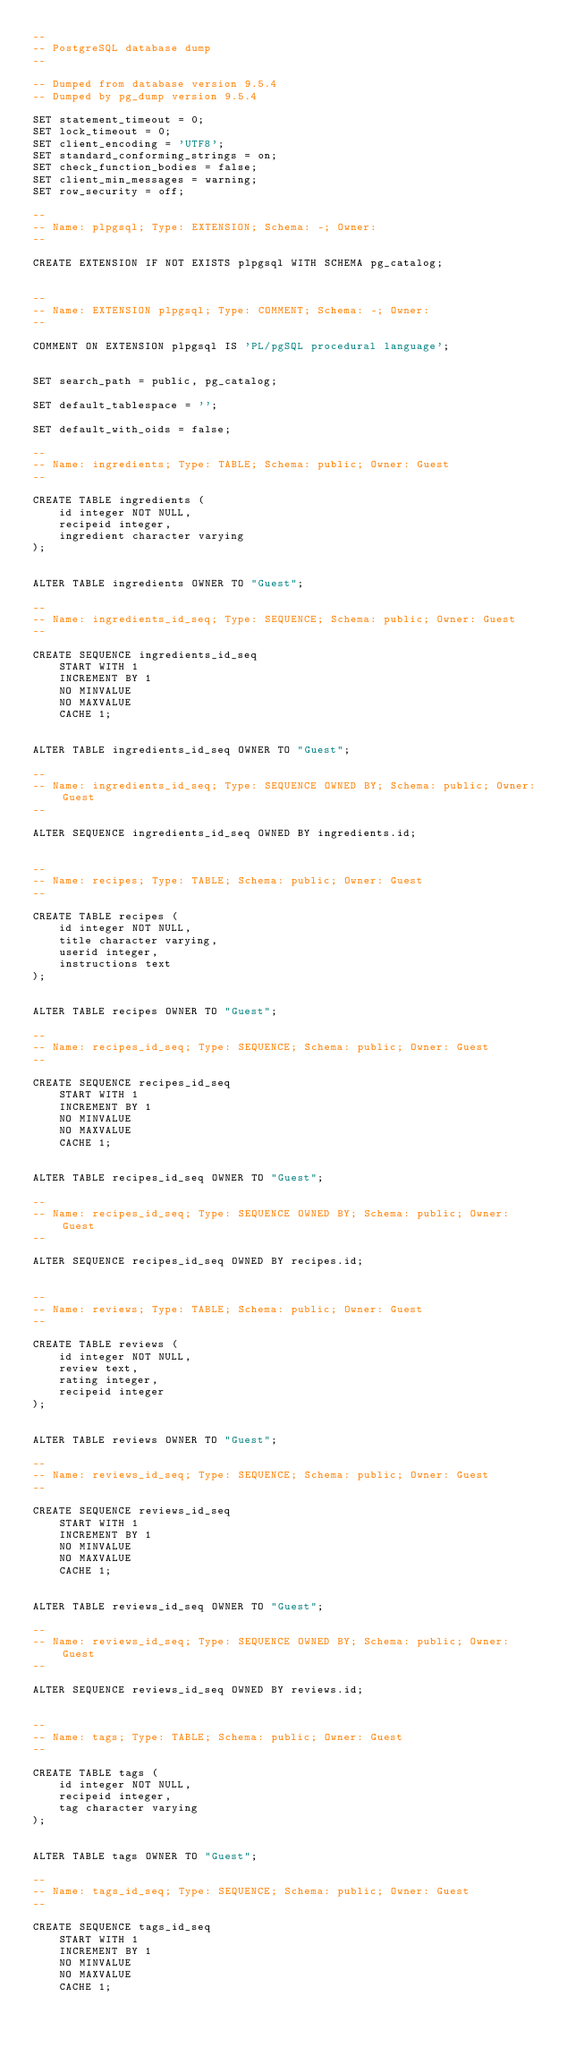<code> <loc_0><loc_0><loc_500><loc_500><_SQL_>--
-- PostgreSQL database dump
--

-- Dumped from database version 9.5.4
-- Dumped by pg_dump version 9.5.4

SET statement_timeout = 0;
SET lock_timeout = 0;
SET client_encoding = 'UTF8';
SET standard_conforming_strings = on;
SET check_function_bodies = false;
SET client_min_messages = warning;
SET row_security = off;

--
-- Name: plpgsql; Type: EXTENSION; Schema: -; Owner: 
--

CREATE EXTENSION IF NOT EXISTS plpgsql WITH SCHEMA pg_catalog;


--
-- Name: EXTENSION plpgsql; Type: COMMENT; Schema: -; Owner: 
--

COMMENT ON EXTENSION plpgsql IS 'PL/pgSQL procedural language';


SET search_path = public, pg_catalog;

SET default_tablespace = '';

SET default_with_oids = false;

--
-- Name: ingredients; Type: TABLE; Schema: public; Owner: Guest
--

CREATE TABLE ingredients (
    id integer NOT NULL,
    recipeid integer,
    ingredient character varying
);


ALTER TABLE ingredients OWNER TO "Guest";

--
-- Name: ingredients_id_seq; Type: SEQUENCE; Schema: public; Owner: Guest
--

CREATE SEQUENCE ingredients_id_seq
    START WITH 1
    INCREMENT BY 1
    NO MINVALUE
    NO MAXVALUE
    CACHE 1;


ALTER TABLE ingredients_id_seq OWNER TO "Guest";

--
-- Name: ingredients_id_seq; Type: SEQUENCE OWNED BY; Schema: public; Owner: Guest
--

ALTER SEQUENCE ingredients_id_seq OWNED BY ingredients.id;


--
-- Name: recipes; Type: TABLE; Schema: public; Owner: Guest
--

CREATE TABLE recipes (
    id integer NOT NULL,
    title character varying,
    userid integer,
    instructions text
);


ALTER TABLE recipes OWNER TO "Guest";

--
-- Name: recipes_id_seq; Type: SEQUENCE; Schema: public; Owner: Guest
--

CREATE SEQUENCE recipes_id_seq
    START WITH 1
    INCREMENT BY 1
    NO MINVALUE
    NO MAXVALUE
    CACHE 1;


ALTER TABLE recipes_id_seq OWNER TO "Guest";

--
-- Name: recipes_id_seq; Type: SEQUENCE OWNED BY; Schema: public; Owner: Guest
--

ALTER SEQUENCE recipes_id_seq OWNED BY recipes.id;


--
-- Name: reviews; Type: TABLE; Schema: public; Owner: Guest
--

CREATE TABLE reviews (
    id integer NOT NULL,
    review text,
    rating integer,
    recipeid integer
);


ALTER TABLE reviews OWNER TO "Guest";

--
-- Name: reviews_id_seq; Type: SEQUENCE; Schema: public; Owner: Guest
--

CREATE SEQUENCE reviews_id_seq
    START WITH 1
    INCREMENT BY 1
    NO MINVALUE
    NO MAXVALUE
    CACHE 1;


ALTER TABLE reviews_id_seq OWNER TO "Guest";

--
-- Name: reviews_id_seq; Type: SEQUENCE OWNED BY; Schema: public; Owner: Guest
--

ALTER SEQUENCE reviews_id_seq OWNED BY reviews.id;


--
-- Name: tags; Type: TABLE; Schema: public; Owner: Guest
--

CREATE TABLE tags (
    id integer NOT NULL,
    recipeid integer,
    tag character varying
);


ALTER TABLE tags OWNER TO "Guest";

--
-- Name: tags_id_seq; Type: SEQUENCE; Schema: public; Owner: Guest
--

CREATE SEQUENCE tags_id_seq
    START WITH 1
    INCREMENT BY 1
    NO MINVALUE
    NO MAXVALUE
    CACHE 1;

</code> 